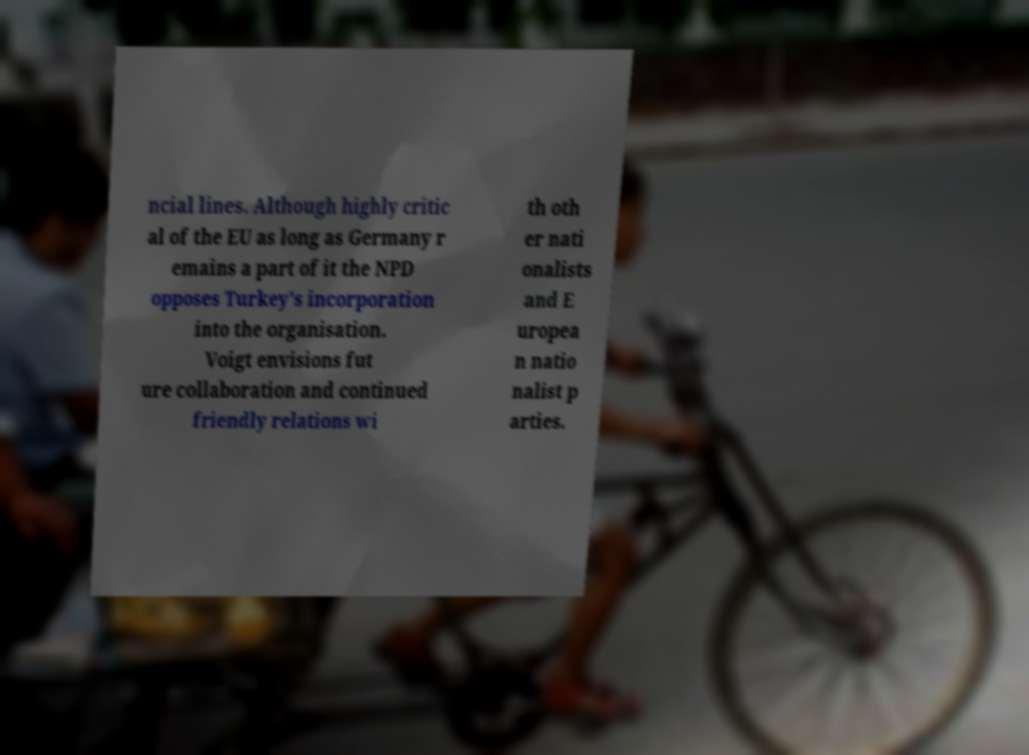Could you assist in decoding the text presented in this image and type it out clearly? ncial lines. Although highly critic al of the EU as long as Germany r emains a part of it the NPD opposes Turkey's incorporation into the organisation. Voigt envisions fut ure collaboration and continued friendly relations wi th oth er nati onalists and E uropea n natio nalist p arties. 